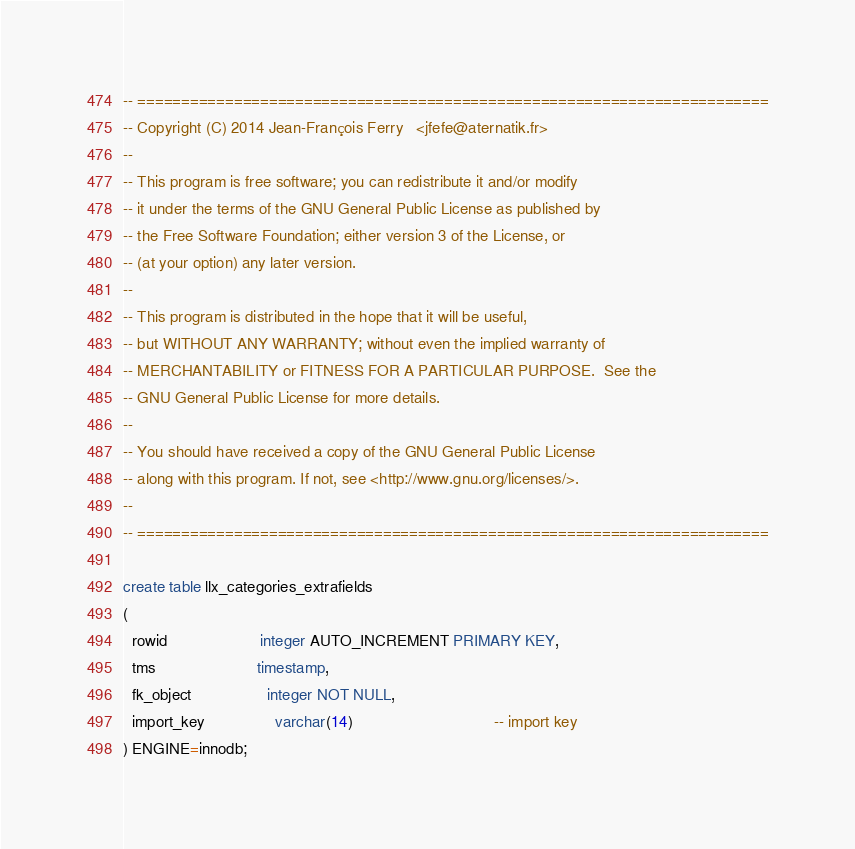Convert code to text. <code><loc_0><loc_0><loc_500><loc_500><_SQL_>-- ========================================================================
-- Copyright (C) 2014 Jean-François Ferry	<jfefe@aternatik.fr>
--
-- This program is free software; you can redistribute it and/or modify
-- it under the terms of the GNU General Public License as published by
-- the Free Software Foundation; either version 3 of the License, or
-- (at your option) any later version.
--
-- This program is distributed in the hope that it will be useful,
-- but WITHOUT ANY WARRANTY; without even the implied warranty of
-- MERCHANTABILITY or FITNESS FOR A PARTICULAR PURPOSE.  See the
-- GNU General Public License for more details.
--
-- You should have received a copy of the GNU General Public License
-- along with this program. If not, see <http://www.gnu.org/licenses/>.
--
-- ========================================================================

create table llx_categories_extrafields
(
  rowid                     integer AUTO_INCREMENT PRIMARY KEY,
  tms                       timestamp,
  fk_object                 integer NOT NULL,
  import_key                varchar(14)                          		-- import key
) ENGINE=innodb;

</code> 